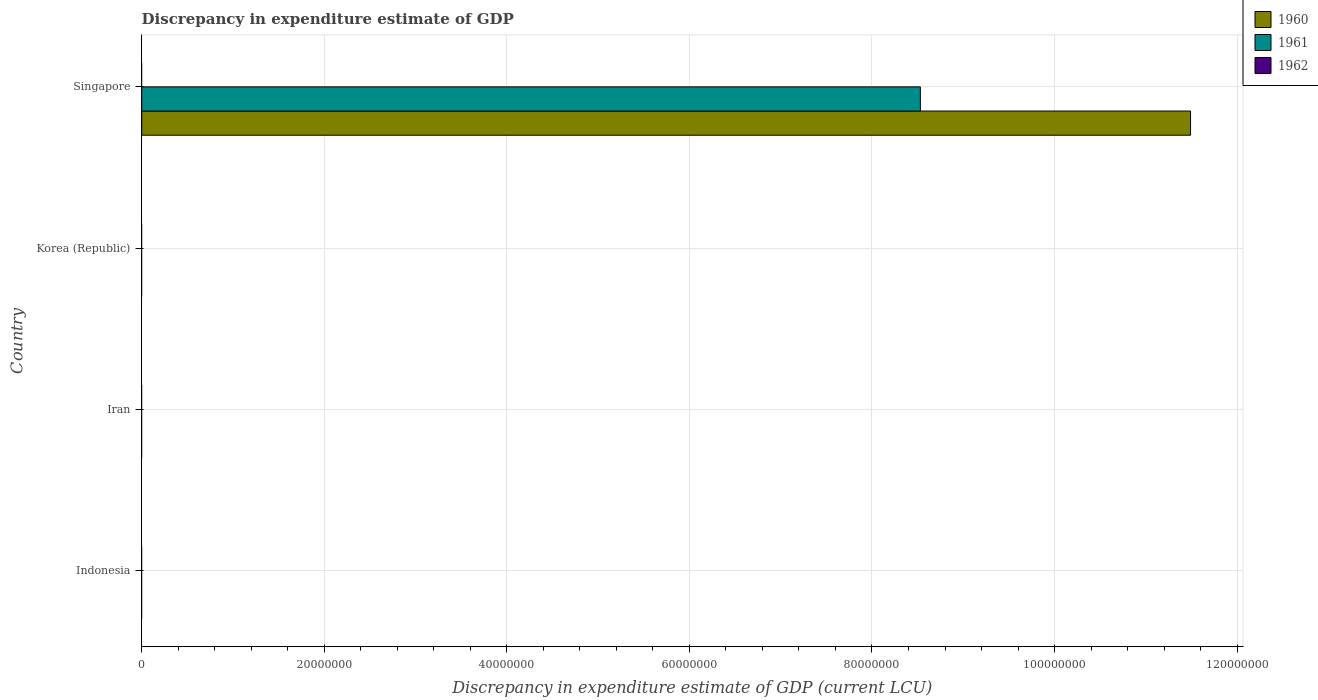Are the number of bars per tick equal to the number of legend labels?
Your answer should be very brief. No. Are the number of bars on each tick of the Y-axis equal?
Your answer should be compact. No. What is the label of the 2nd group of bars from the top?
Offer a very short reply. Korea (Republic). In how many cases, is the number of bars for a given country not equal to the number of legend labels?
Your response must be concise. 4. What is the discrepancy in expenditure estimate of GDP in 1960 in Iran?
Ensure brevity in your answer.  0. Across all countries, what is the maximum discrepancy in expenditure estimate of GDP in 1961?
Your response must be concise. 8.53e+07. Across all countries, what is the minimum discrepancy in expenditure estimate of GDP in 1961?
Offer a terse response. 0. In which country was the discrepancy in expenditure estimate of GDP in 1960 maximum?
Ensure brevity in your answer.  Singapore. What is the total discrepancy in expenditure estimate of GDP in 1961 in the graph?
Offer a very short reply. 8.53e+07. What is the difference between the discrepancy in expenditure estimate of GDP in 1962 in Korea (Republic) and the discrepancy in expenditure estimate of GDP in 1961 in Iran?
Provide a short and direct response. 0. What is the average discrepancy in expenditure estimate of GDP in 1960 per country?
Your answer should be compact. 2.87e+07. In how many countries, is the discrepancy in expenditure estimate of GDP in 1961 greater than 4000000 LCU?
Keep it short and to the point. 1. What is the difference between the highest and the lowest discrepancy in expenditure estimate of GDP in 1960?
Provide a short and direct response. 1.15e+08. In how many countries, is the discrepancy in expenditure estimate of GDP in 1962 greater than the average discrepancy in expenditure estimate of GDP in 1962 taken over all countries?
Offer a very short reply. 0. Is it the case that in every country, the sum of the discrepancy in expenditure estimate of GDP in 1961 and discrepancy in expenditure estimate of GDP in 1962 is greater than the discrepancy in expenditure estimate of GDP in 1960?
Offer a terse response. No. Are all the bars in the graph horizontal?
Your response must be concise. Yes. How many countries are there in the graph?
Keep it short and to the point. 4. Does the graph contain grids?
Provide a succinct answer. Yes. How many legend labels are there?
Give a very brief answer. 3. What is the title of the graph?
Keep it short and to the point. Discrepancy in expenditure estimate of GDP. What is the label or title of the X-axis?
Ensure brevity in your answer.  Discrepancy in expenditure estimate of GDP (current LCU). What is the label or title of the Y-axis?
Give a very brief answer. Country. What is the Discrepancy in expenditure estimate of GDP (current LCU) in 1960 in Indonesia?
Your answer should be compact. 0. What is the Discrepancy in expenditure estimate of GDP (current LCU) of 1961 in Indonesia?
Make the answer very short. 0. What is the Discrepancy in expenditure estimate of GDP (current LCU) of 1960 in Iran?
Ensure brevity in your answer.  0. What is the Discrepancy in expenditure estimate of GDP (current LCU) of 1960 in Korea (Republic)?
Provide a short and direct response. 0. What is the Discrepancy in expenditure estimate of GDP (current LCU) in 1961 in Korea (Republic)?
Offer a terse response. 0. What is the Discrepancy in expenditure estimate of GDP (current LCU) in 1960 in Singapore?
Give a very brief answer. 1.15e+08. What is the Discrepancy in expenditure estimate of GDP (current LCU) in 1961 in Singapore?
Give a very brief answer. 8.53e+07. What is the Discrepancy in expenditure estimate of GDP (current LCU) of 1962 in Singapore?
Your answer should be compact. 0. Across all countries, what is the maximum Discrepancy in expenditure estimate of GDP (current LCU) in 1960?
Offer a terse response. 1.15e+08. Across all countries, what is the maximum Discrepancy in expenditure estimate of GDP (current LCU) in 1961?
Make the answer very short. 8.53e+07. Across all countries, what is the minimum Discrepancy in expenditure estimate of GDP (current LCU) of 1961?
Keep it short and to the point. 0. What is the total Discrepancy in expenditure estimate of GDP (current LCU) of 1960 in the graph?
Your response must be concise. 1.15e+08. What is the total Discrepancy in expenditure estimate of GDP (current LCU) of 1961 in the graph?
Provide a short and direct response. 8.53e+07. What is the total Discrepancy in expenditure estimate of GDP (current LCU) of 1962 in the graph?
Your answer should be very brief. 0. What is the average Discrepancy in expenditure estimate of GDP (current LCU) of 1960 per country?
Your answer should be very brief. 2.87e+07. What is the average Discrepancy in expenditure estimate of GDP (current LCU) of 1961 per country?
Offer a very short reply. 2.13e+07. What is the difference between the Discrepancy in expenditure estimate of GDP (current LCU) of 1960 and Discrepancy in expenditure estimate of GDP (current LCU) of 1961 in Singapore?
Your response must be concise. 2.96e+07. What is the difference between the highest and the lowest Discrepancy in expenditure estimate of GDP (current LCU) in 1960?
Keep it short and to the point. 1.15e+08. What is the difference between the highest and the lowest Discrepancy in expenditure estimate of GDP (current LCU) of 1961?
Give a very brief answer. 8.53e+07. 